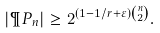<formula> <loc_0><loc_0><loc_500><loc_500>| \P P _ { n } | \geq 2 ^ { ( 1 - 1 / r + \varepsilon ) \binom { n } { 2 } } .</formula> 